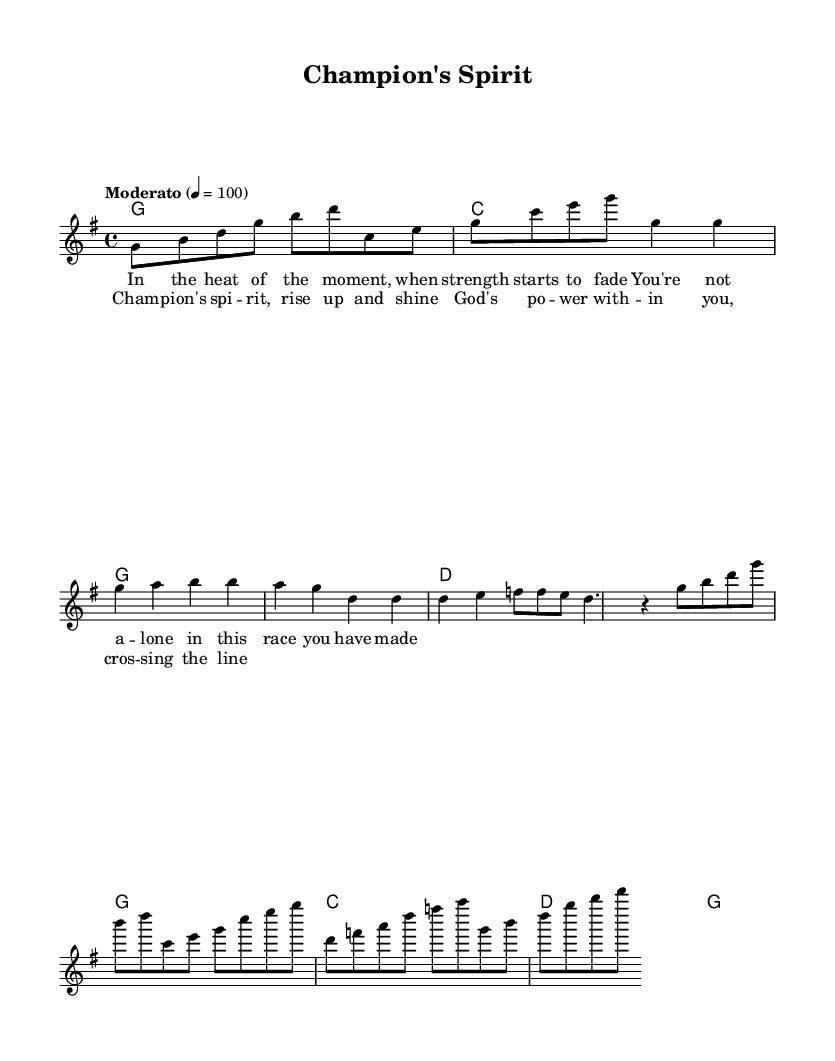What is the key signature of this music? The key signature can be identified by looking at the beginning of the music sheet, which shows the sharp or flat symbols on the staff lines. In this case, there are no sharps or flats, indicating that it is in G major, which has one sharp.
Answer: G major What is the time signature of this music? The time signature is found at the beginning of the score, indicated by the numbers shown in a fraction format. Here, it displays 4 over 4, meaning there are four beats in each measure and the quarter note gets one beat.
Answer: 4/4 What is the tempo marking of this music? The tempo marking is indicated near the beginning and tells the performer how fast to play the piece. In this sheet music, it states “Moderato” with a specific metronome marking of 100, meaning moderate speed.
Answer: 100 How many measures are in the chorus section? By inspecting the specific section labeled as the chorus, we count the individual measures (bars) marked, leading to a total of four distinct measures.
Answer: 4 What is the primary theme expressed in the lyrics of the first verse? The first verse discusses perseverance and the idea of not being alone in challenging moments. This content reflects a supportive message for athletes, emphasizing strength and endurance.
Answer: Strength What is the harmonic progression in the verse section? The harmonic progression for the verse indicates which chords are played throughout this section, which are G major, repeated G major, D major, and D major again. This results in a clear repetitive pattern that supports the melody.
Answer: G, D What main message is communicated in the chorus? By analyzing the lyrics provided in the chorus, the central message revolves around empowerment and the uplifting spirit of a champion, encapsulating the essence of strength through faith.
Answer: Empowerment 